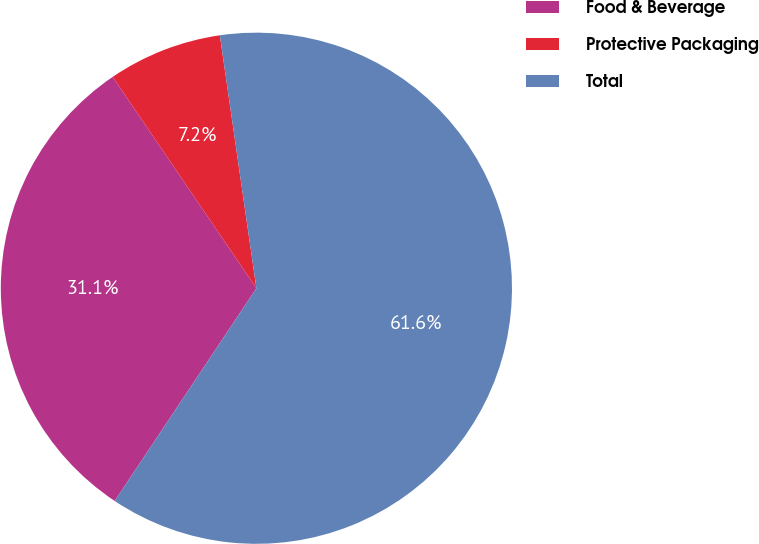<chart> <loc_0><loc_0><loc_500><loc_500><pie_chart><fcel>Food & Beverage<fcel>Protective Packaging<fcel>Total<nl><fcel>31.14%<fcel>7.22%<fcel>61.63%<nl></chart> 